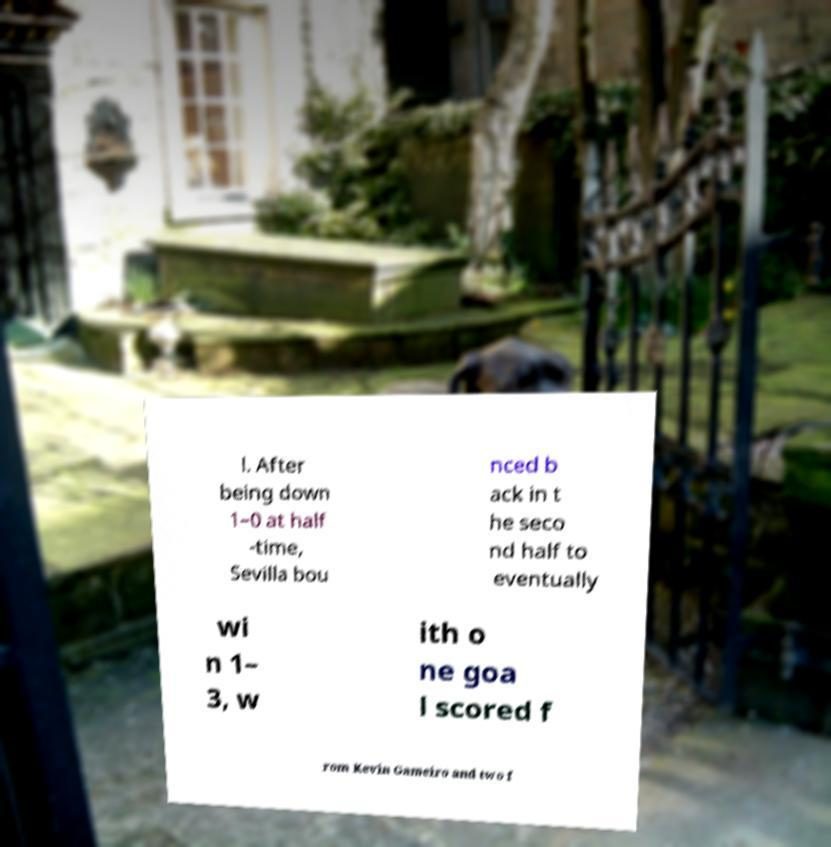What messages or text are displayed in this image? I need them in a readable, typed format. l. After being down 1–0 at half -time, Sevilla bou nced b ack in t he seco nd half to eventually wi n 1– 3, w ith o ne goa l scored f rom Kevin Gameiro and two f 